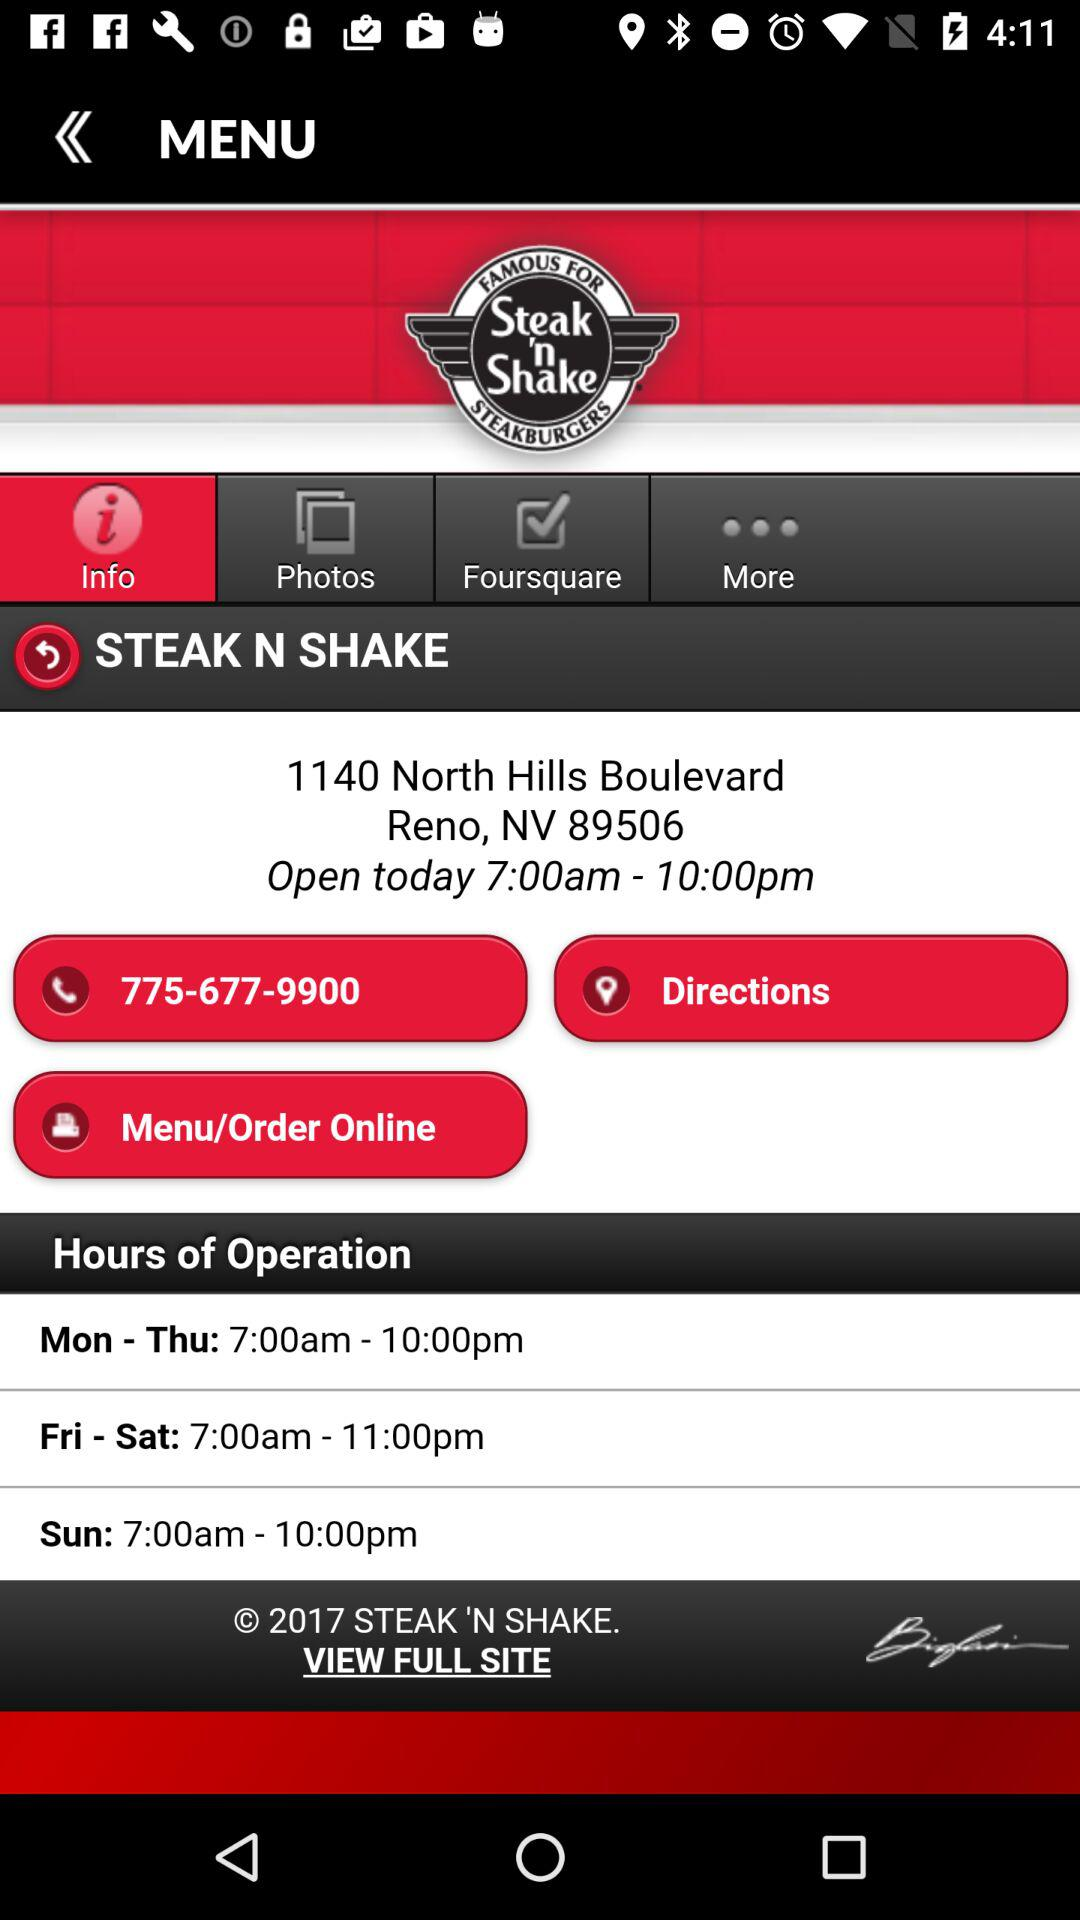Which option is selected in the menu? The selected option is "Info". 